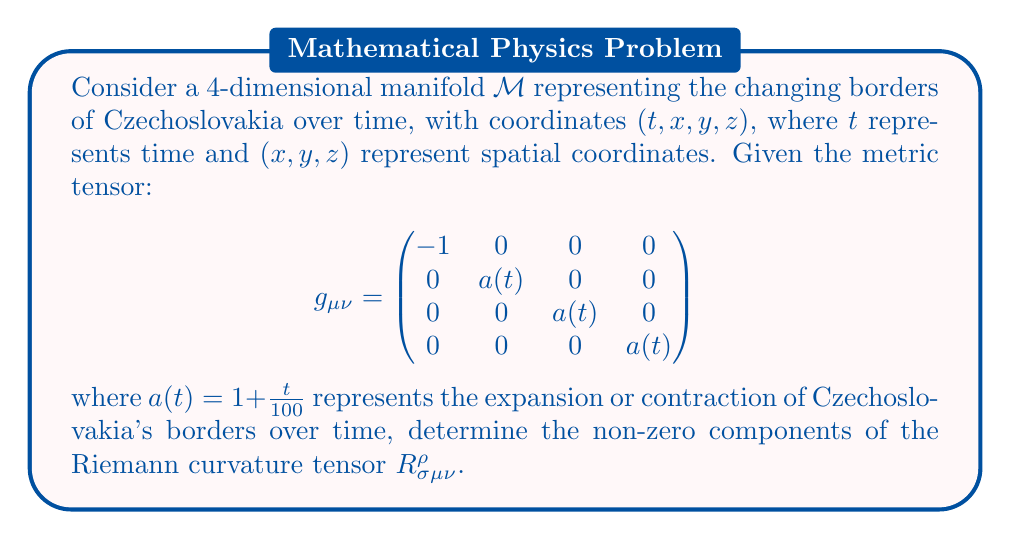Can you answer this question? To determine the Riemann curvature tensor, we'll follow these steps:

1) First, calculate the Christoffel symbols $\Gamma^{\rho}_{\mu\nu}$ using:
   $$\Gamma^{\rho}_{\mu\nu} = \frac{1}{2}g^{\rho\sigma}(\partial_{\mu}g_{\nu\sigma} + \partial_{\nu}g_{\mu\sigma} - \partial_{\sigma}g_{\mu\nu})$$

2) The non-zero Christoffel symbols are:
   $$\Gamma^{i}_{0i} = \Gamma^{i}_{i0} = \frac{\dot{a}}{2a}, \quad i = 1,2,3$$
   where $\dot{a} = \frac{da}{dt} = \frac{1}{100}$

3) Calculate the Riemann tensor using:
   $$R^{\rho}_{\sigma\mu\nu} = \partial_{\mu}\Gamma^{\rho}_{\nu\sigma} - \partial_{\nu}\Gamma^{\rho}_{\mu\sigma} + \Gamma^{\rho}_{\mu\lambda}\Gamma^{\lambda}_{\nu\sigma} - \Gamma^{\rho}_{\nu\lambda}\Gamma^{\lambda}_{\mu\sigma}$$

4) The non-zero components are:
   $$R^{i}_{0j0} = -R^{i}_{00j} = -\frac{\ddot{a}}{a}\delta^{i}_{j}, \quad i,j = 1,2,3$$
   $$R^{i}_{jkl} = \frac{\dot{a}^2}{a^2}(\delta^{i}_{k}\delta_{jl} - \delta^{i}_{l}\delta_{jk}), \quad i,j,k,l = 1,2,3$$

5) Substitute $a(t) = 1 + \frac{t}{100}$:
   $$\dot{a} = \frac{1}{100}, \quad \ddot{a} = 0$$

6) Therefore, the non-zero components simplify to:
   $$R^{i}_{jkl} = \frac{1}{10000(1+\frac{t}{100})^2}(\delta^{i}_{k}\delta_{jl} - \delta^{i}_{l}\delta_{jk}), \quad i,j,k,l = 1,2,3$$
Answer: $R^{i}_{jkl} = \frac{1}{10000(1+\frac{t}{100})^2}(\delta^{i}_{k}\delta_{jl} - \delta^{i}_{l}\delta_{jk})$, for $i,j,k,l = 1,2,3$ 